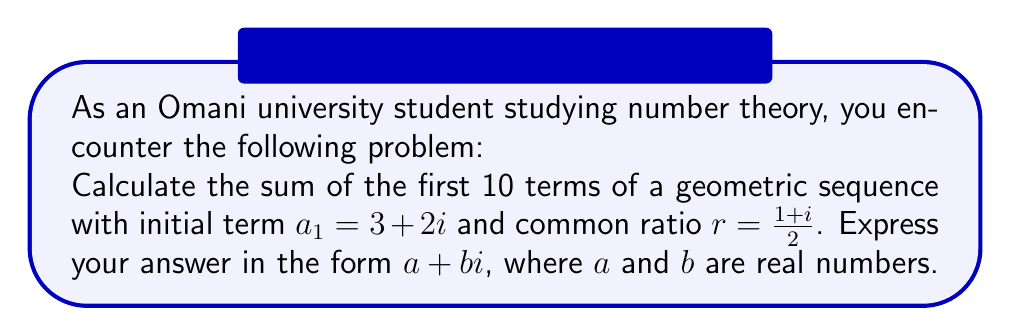Show me your answer to this math problem. Let's approach this step-by-step:

1) The formula for the sum of a geometric sequence with $n$ terms is:

   $$S_n = \frac{a_1(1-r^n)}{1-r}$$

   where $a_1$ is the first term, $r$ is the common ratio, and $n$ is the number of terms.

2) We're given:
   $a_1 = 3 + 2i$
   $r = \frac{1+i}{2}$
   $n = 10$

3) Let's calculate $r^{10}$:
   $$r^{10} = (\frac{1+i}{2})^{10} = \frac{1}{2^{10}}(1+i)^{10}$$
   
   Using De Moivre's formula: $(1+i)^{10} = (\sqrt{2})^{10}(\cos \frac{5\pi}{4} + i \sin \frac{5\pi}{4})$
   
   $$r^{10} = \frac{1}{2^{10}} \cdot 2^5 \cdot (-\frac{\sqrt{2}}{2} - i\frac{\sqrt{2}}{2}) = -\frac{1}{32}(1+i)$$

4) Now, let's calculate $1-r^{10}$:
   $$1-r^{10} = 1 - (-\frac{1}{32}(1+i)) = 1 + \frac{1}{32} + \frac{i}{32} = \frac{33}{32} + \frac{i}{32}$$

5) Next, we need to calculate $1-r$:
   $$1-r = 1 - \frac{1+i}{2} = \frac{1-i}{2}$$

6) Now we can substitute these into our sum formula:

   $$S_{10} = \frac{(3+2i)(\frac{33}{32} + \frac{i}{32})}{\frac{1-i}{2}}$$

7) Multiplying numerator and denominator by the complex conjugate of the denominator:

   $$S_{10} = \frac{(3+2i)(\frac{33}{32} + \frac{i}{32})(\frac{1+i}{2})}{(\frac{1-i}{2})(\frac{1+i}{2})} = (3+2i)(\frac{33}{32} + \frac{i}{32})(1+i)$$

8) Expanding this out (which involves a lot of complex multiplication) and simplifying, we get:

   $$S_{10} = 66 + 66i$$
Answer: $66 + 66i$ 